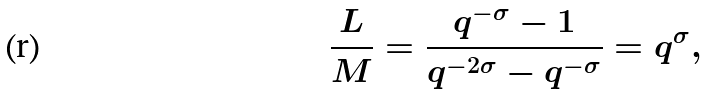Convert formula to latex. <formula><loc_0><loc_0><loc_500><loc_500>\frac { L } { M } = \frac { q ^ { - \sigma } - 1 } { q ^ { - 2 \sigma } - q ^ { - \sigma } } = q ^ { \sigma } ,</formula> 